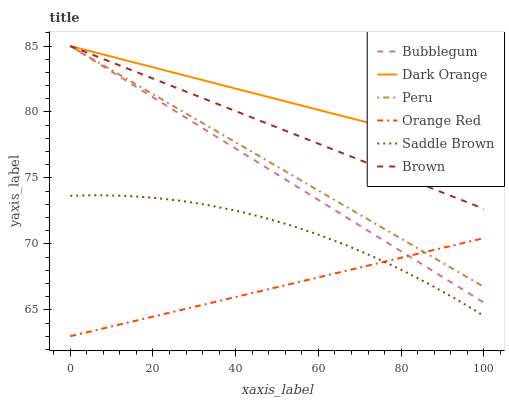Does Orange Red have the minimum area under the curve?
Answer yes or no. Yes. Does Dark Orange have the maximum area under the curve?
Answer yes or no. Yes. Does Brown have the minimum area under the curve?
Answer yes or no. No. Does Brown have the maximum area under the curve?
Answer yes or no. No. Is Orange Red the smoothest?
Answer yes or no. Yes. Is Saddle Brown the roughest?
Answer yes or no. Yes. Is Brown the smoothest?
Answer yes or no. No. Is Brown the roughest?
Answer yes or no. No. Does Orange Red have the lowest value?
Answer yes or no. Yes. Does Brown have the lowest value?
Answer yes or no. No. Does Peru have the highest value?
Answer yes or no. Yes. Does Orange Red have the highest value?
Answer yes or no. No. Is Saddle Brown less than Brown?
Answer yes or no. Yes. Is Dark Orange greater than Orange Red?
Answer yes or no. Yes. Does Brown intersect Peru?
Answer yes or no. Yes. Is Brown less than Peru?
Answer yes or no. No. Is Brown greater than Peru?
Answer yes or no. No. Does Saddle Brown intersect Brown?
Answer yes or no. No. 